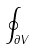<formula> <loc_0><loc_0><loc_500><loc_500>\oint _ { \partial V }</formula> 